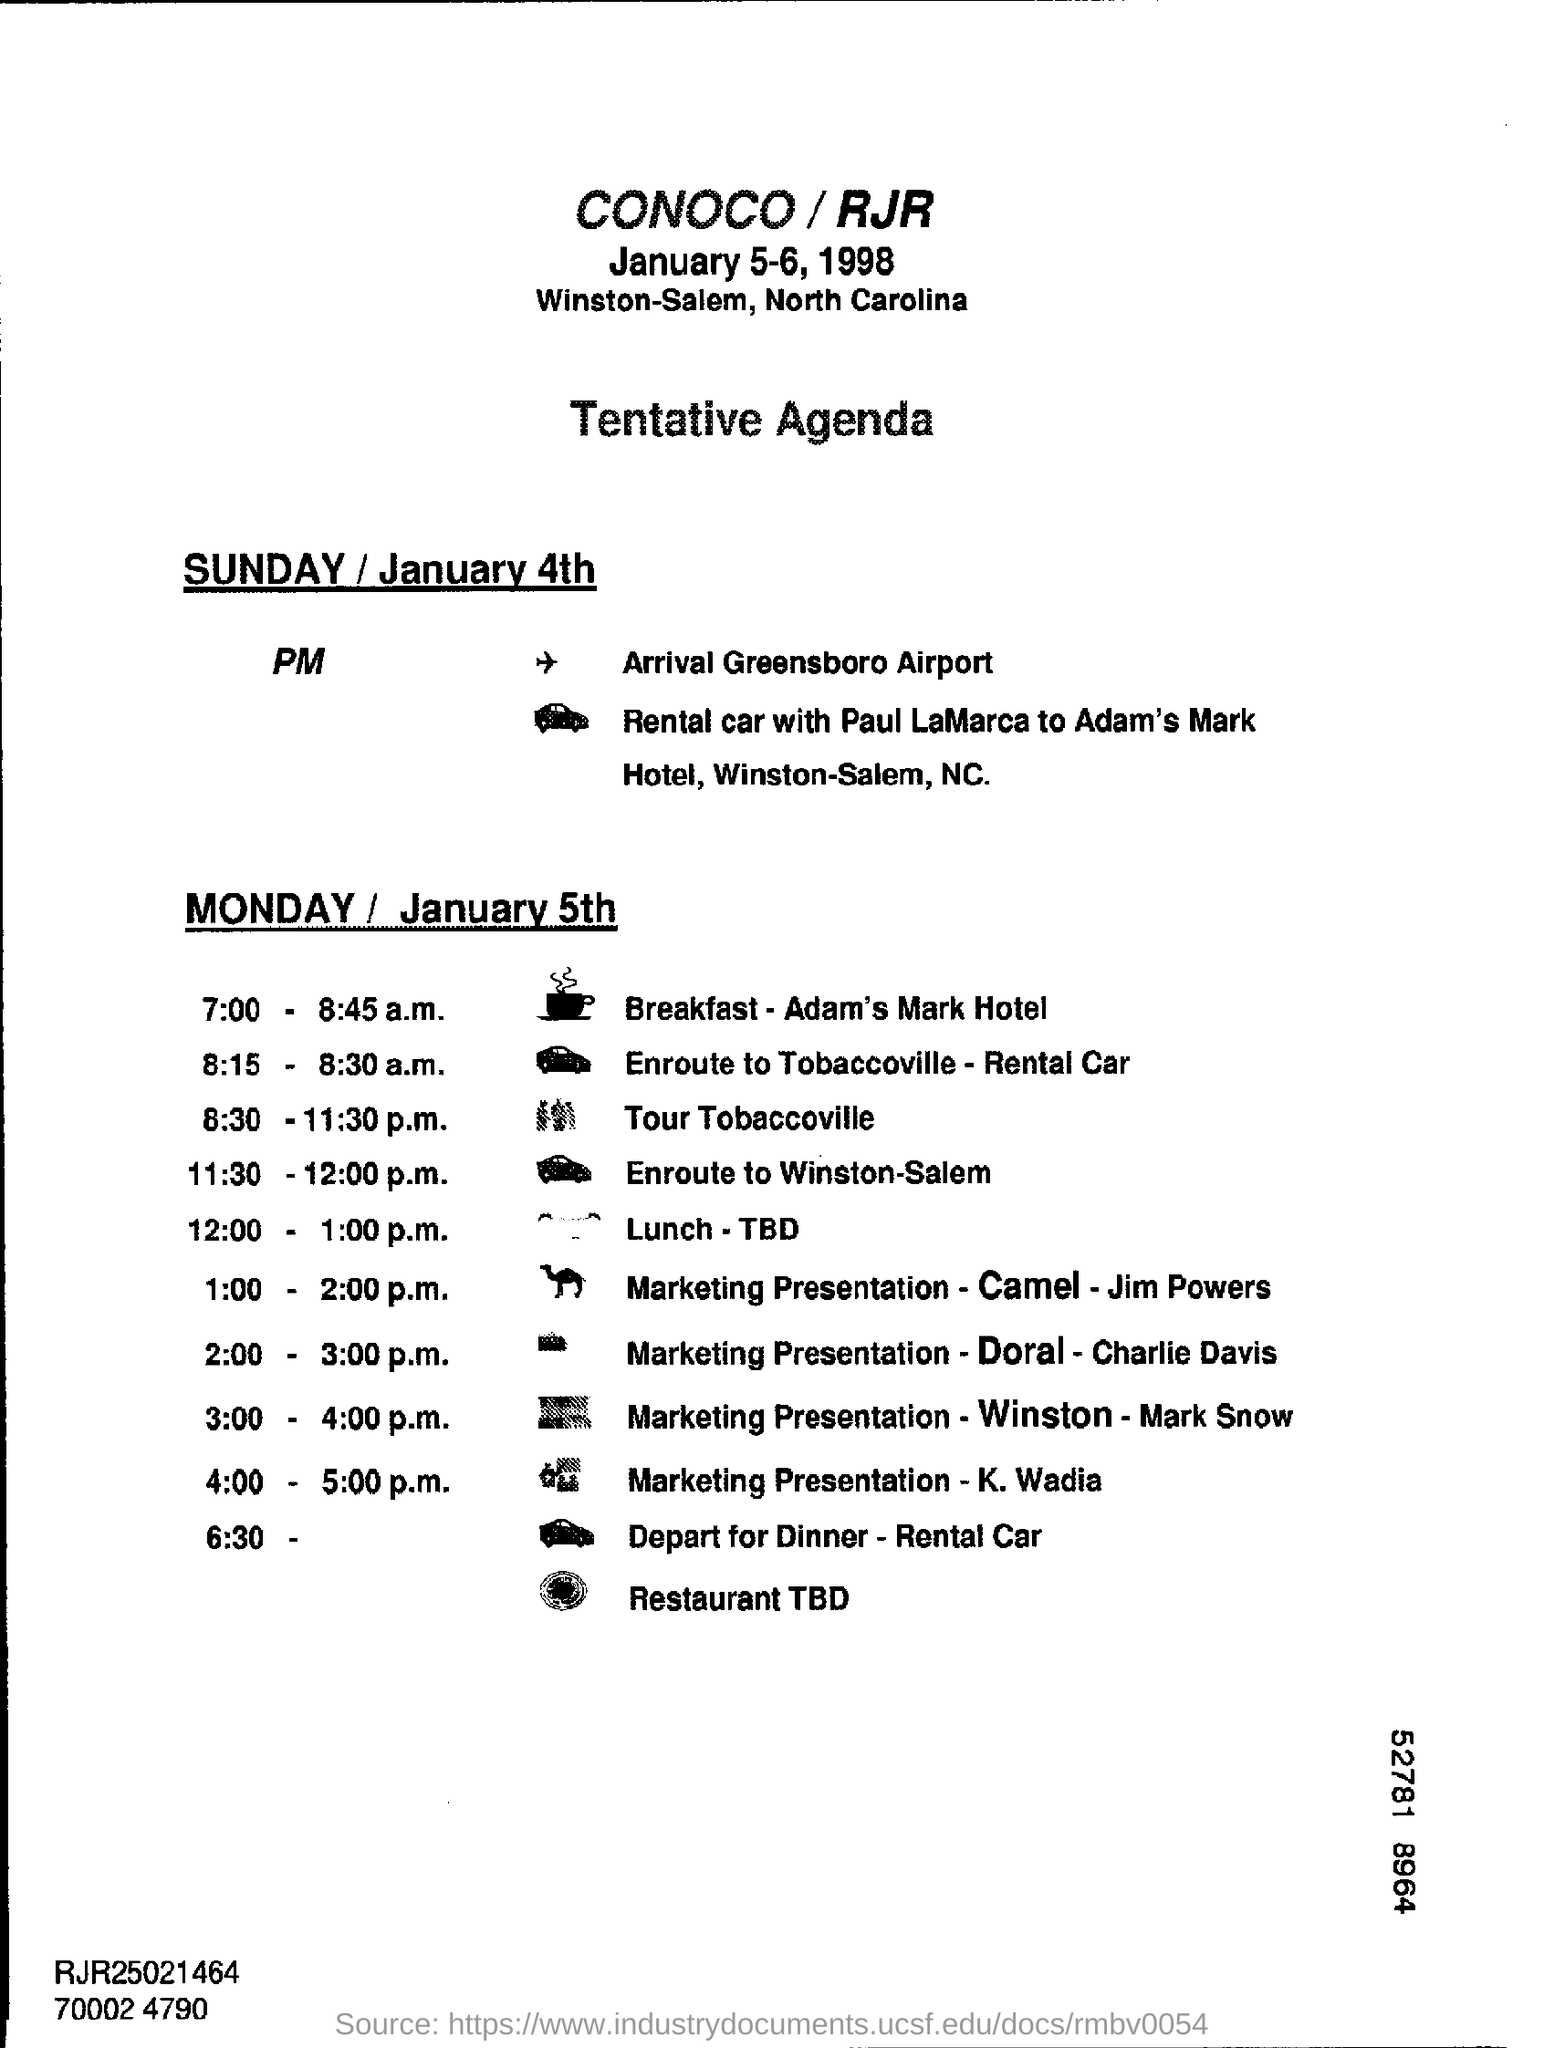Outline some significant characteristics in this image. This is a document that serves as a tentative agenda. The Marketing Presentation - Camel - Jim Powers is scheduled to occur at 1:00-2:00 p.m. The Marketing Presentation by K. Wadia is scheduled for MONDAY / January 5th. The date of arrival at Greensboro Airport is Sunday, January 4th. 